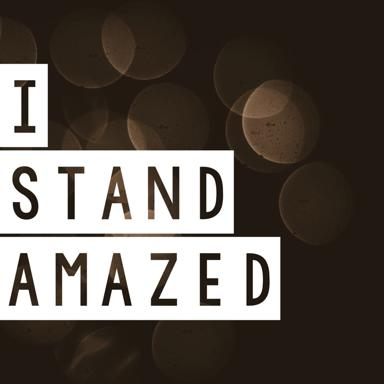What might the blurred background represent in this image? The blurred background featuring a bokeh effect might symbolize a state of focus or being emotionally overwhelmed, where the surroundings become indistinct as the individual stands amazed at the moment's experience or realization. 